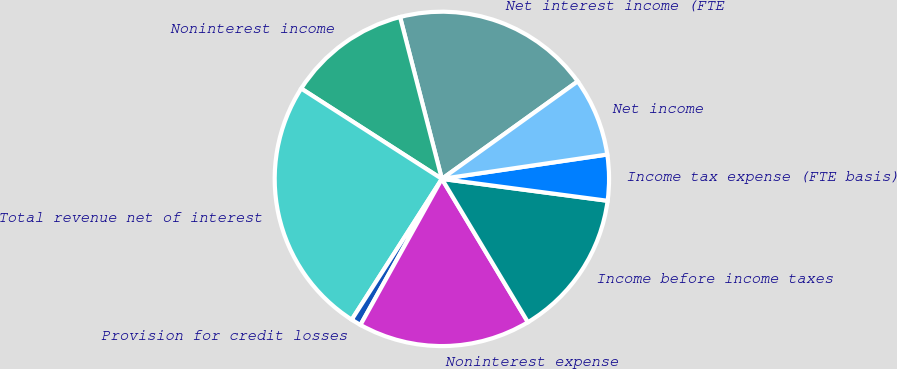<chart> <loc_0><loc_0><loc_500><loc_500><pie_chart><fcel>Net interest income (FTE<fcel>Noninterest income<fcel>Total revenue net of interest<fcel>Provision for credit losses<fcel>Noninterest expense<fcel>Income before income taxes<fcel>Income tax expense (FTE basis)<fcel>Net income<nl><fcel>19.11%<fcel>11.89%<fcel>25.02%<fcel>0.97%<fcel>16.7%<fcel>14.3%<fcel>4.42%<fcel>7.58%<nl></chart> 